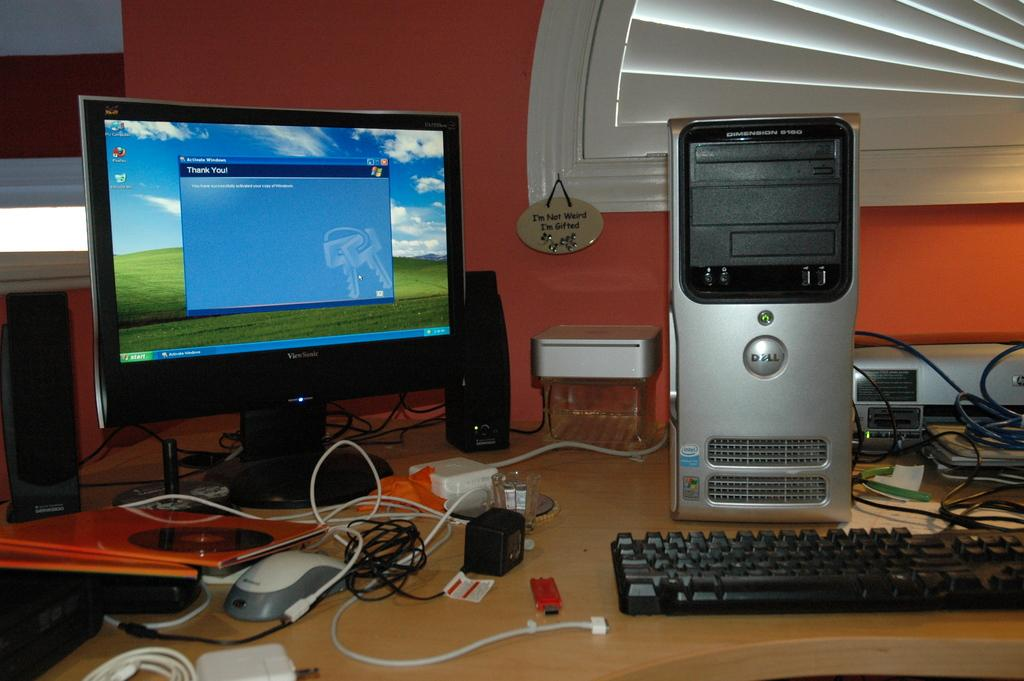<image>
Create a compact narrative representing the image presented. A computer sits on a desk with a small placard that says "I'm not weird, I'm gifted." 